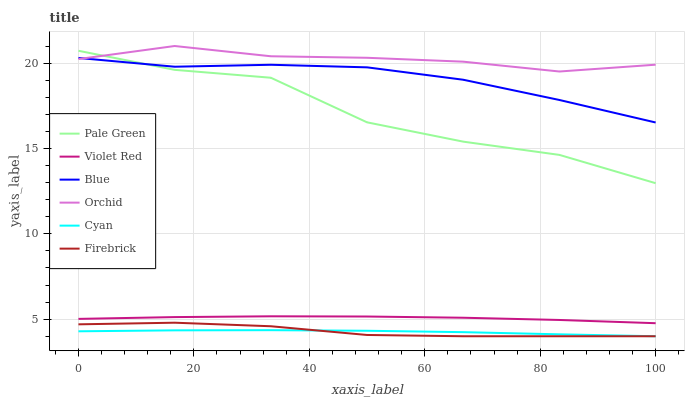Does Cyan have the minimum area under the curve?
Answer yes or no. Yes. Does Orchid have the maximum area under the curve?
Answer yes or no. Yes. Does Violet Red have the minimum area under the curve?
Answer yes or no. No. Does Violet Red have the maximum area under the curve?
Answer yes or no. No. Is Cyan the smoothest?
Answer yes or no. Yes. Is Pale Green the roughest?
Answer yes or no. Yes. Is Violet Red the smoothest?
Answer yes or no. No. Is Violet Red the roughest?
Answer yes or no. No. Does Violet Red have the lowest value?
Answer yes or no. No. Does Orchid have the highest value?
Answer yes or no. Yes. Does Violet Red have the highest value?
Answer yes or no. No. Is Violet Red less than Pale Green?
Answer yes or no. Yes. Is Pale Green greater than Cyan?
Answer yes or no. Yes. Does Pale Green intersect Blue?
Answer yes or no. Yes. Is Pale Green less than Blue?
Answer yes or no. No. Is Pale Green greater than Blue?
Answer yes or no. No. Does Violet Red intersect Pale Green?
Answer yes or no. No. 